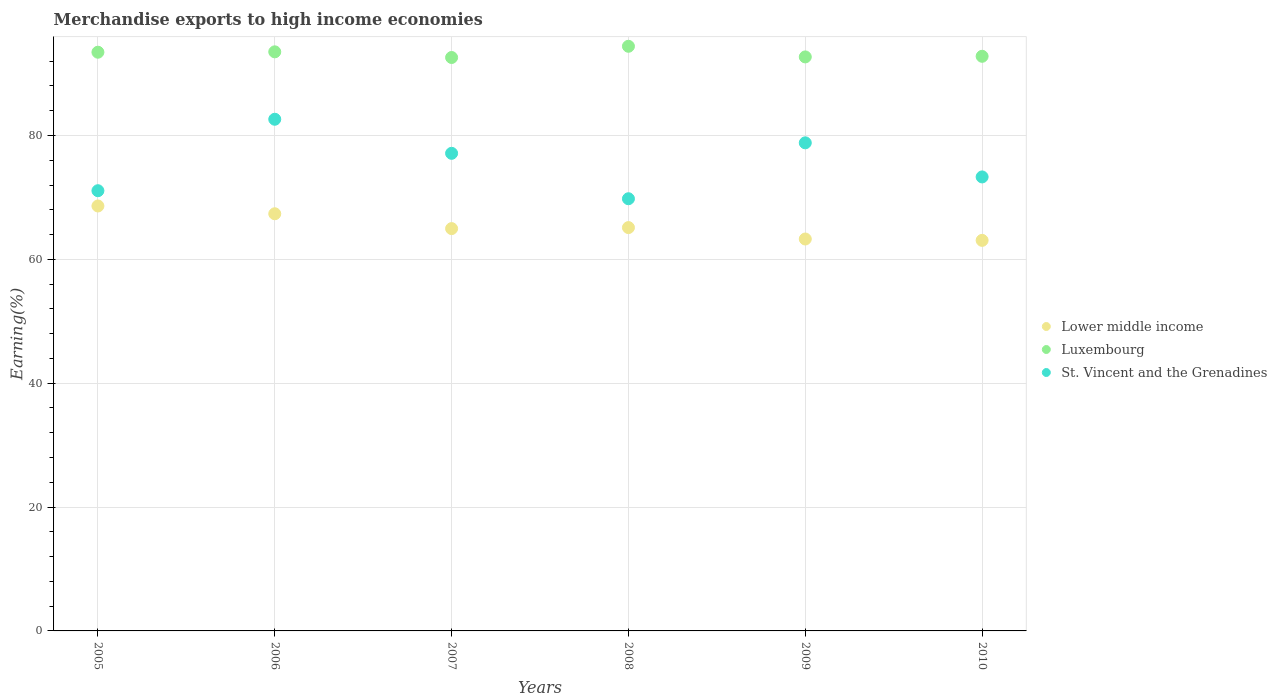How many different coloured dotlines are there?
Keep it short and to the point. 3. Is the number of dotlines equal to the number of legend labels?
Provide a short and direct response. Yes. What is the percentage of amount earned from merchandise exports in St. Vincent and the Grenadines in 2008?
Provide a succinct answer. 69.79. Across all years, what is the maximum percentage of amount earned from merchandise exports in Lower middle income?
Your response must be concise. 68.62. Across all years, what is the minimum percentage of amount earned from merchandise exports in Luxembourg?
Offer a very short reply. 92.6. What is the total percentage of amount earned from merchandise exports in Lower middle income in the graph?
Ensure brevity in your answer.  392.45. What is the difference between the percentage of amount earned from merchandise exports in St. Vincent and the Grenadines in 2005 and that in 2010?
Give a very brief answer. -2.23. What is the difference between the percentage of amount earned from merchandise exports in Luxembourg in 2010 and the percentage of amount earned from merchandise exports in St. Vincent and the Grenadines in 2009?
Make the answer very short. 13.98. What is the average percentage of amount earned from merchandise exports in Lower middle income per year?
Your answer should be compact. 65.41. In the year 2009, what is the difference between the percentage of amount earned from merchandise exports in St. Vincent and the Grenadines and percentage of amount earned from merchandise exports in Lower middle income?
Provide a succinct answer. 15.53. What is the ratio of the percentage of amount earned from merchandise exports in Lower middle income in 2005 to that in 2006?
Make the answer very short. 1.02. Is the difference between the percentage of amount earned from merchandise exports in St. Vincent and the Grenadines in 2006 and 2010 greater than the difference between the percentage of amount earned from merchandise exports in Lower middle income in 2006 and 2010?
Offer a terse response. Yes. What is the difference between the highest and the second highest percentage of amount earned from merchandise exports in St. Vincent and the Grenadines?
Your answer should be very brief. 3.81. What is the difference between the highest and the lowest percentage of amount earned from merchandise exports in Lower middle income?
Your answer should be compact. 5.55. In how many years, is the percentage of amount earned from merchandise exports in Luxembourg greater than the average percentage of amount earned from merchandise exports in Luxembourg taken over all years?
Offer a terse response. 3. Is it the case that in every year, the sum of the percentage of amount earned from merchandise exports in Lower middle income and percentage of amount earned from merchandise exports in Luxembourg  is greater than the percentage of amount earned from merchandise exports in St. Vincent and the Grenadines?
Offer a very short reply. Yes. Does the percentage of amount earned from merchandise exports in Lower middle income monotonically increase over the years?
Provide a succinct answer. No. Is the percentage of amount earned from merchandise exports in Lower middle income strictly greater than the percentage of amount earned from merchandise exports in St. Vincent and the Grenadines over the years?
Provide a succinct answer. No. How many dotlines are there?
Offer a terse response. 3. Does the graph contain grids?
Ensure brevity in your answer.  Yes. Where does the legend appear in the graph?
Your response must be concise. Center right. How are the legend labels stacked?
Provide a short and direct response. Vertical. What is the title of the graph?
Ensure brevity in your answer.  Merchandise exports to high income economies. What is the label or title of the X-axis?
Your answer should be very brief. Years. What is the label or title of the Y-axis?
Offer a very short reply. Earning(%). What is the Earning(%) in Lower middle income in 2005?
Keep it short and to the point. 68.62. What is the Earning(%) in Luxembourg in 2005?
Your answer should be very brief. 93.45. What is the Earning(%) of St. Vincent and the Grenadines in 2005?
Give a very brief answer. 71.09. What is the Earning(%) in Lower middle income in 2006?
Provide a short and direct response. 67.37. What is the Earning(%) in Luxembourg in 2006?
Your answer should be compact. 93.52. What is the Earning(%) in St. Vincent and the Grenadines in 2006?
Offer a terse response. 82.63. What is the Earning(%) of Lower middle income in 2007?
Your response must be concise. 64.97. What is the Earning(%) in Luxembourg in 2007?
Give a very brief answer. 92.6. What is the Earning(%) of St. Vincent and the Grenadines in 2007?
Provide a succinct answer. 77.13. What is the Earning(%) of Lower middle income in 2008?
Keep it short and to the point. 65.13. What is the Earning(%) in Luxembourg in 2008?
Your answer should be very brief. 94.41. What is the Earning(%) of St. Vincent and the Grenadines in 2008?
Keep it short and to the point. 69.79. What is the Earning(%) of Lower middle income in 2009?
Ensure brevity in your answer.  63.29. What is the Earning(%) of Luxembourg in 2009?
Make the answer very short. 92.69. What is the Earning(%) of St. Vincent and the Grenadines in 2009?
Make the answer very short. 78.82. What is the Earning(%) in Lower middle income in 2010?
Your answer should be very brief. 63.07. What is the Earning(%) of Luxembourg in 2010?
Your answer should be very brief. 92.79. What is the Earning(%) in St. Vincent and the Grenadines in 2010?
Make the answer very short. 73.31. Across all years, what is the maximum Earning(%) of Lower middle income?
Your answer should be very brief. 68.62. Across all years, what is the maximum Earning(%) in Luxembourg?
Your answer should be compact. 94.41. Across all years, what is the maximum Earning(%) in St. Vincent and the Grenadines?
Your response must be concise. 82.63. Across all years, what is the minimum Earning(%) in Lower middle income?
Give a very brief answer. 63.07. Across all years, what is the minimum Earning(%) of Luxembourg?
Make the answer very short. 92.6. Across all years, what is the minimum Earning(%) in St. Vincent and the Grenadines?
Offer a very short reply. 69.79. What is the total Earning(%) of Lower middle income in the graph?
Offer a terse response. 392.45. What is the total Earning(%) in Luxembourg in the graph?
Offer a very short reply. 559.47. What is the total Earning(%) in St. Vincent and the Grenadines in the graph?
Offer a terse response. 452.76. What is the difference between the Earning(%) of Lower middle income in 2005 and that in 2006?
Provide a short and direct response. 1.26. What is the difference between the Earning(%) of Luxembourg in 2005 and that in 2006?
Your answer should be compact. -0.06. What is the difference between the Earning(%) in St. Vincent and the Grenadines in 2005 and that in 2006?
Provide a short and direct response. -11.54. What is the difference between the Earning(%) in Lower middle income in 2005 and that in 2007?
Provide a succinct answer. 3.65. What is the difference between the Earning(%) of Luxembourg in 2005 and that in 2007?
Give a very brief answer. 0.85. What is the difference between the Earning(%) in St. Vincent and the Grenadines in 2005 and that in 2007?
Your answer should be compact. -6.04. What is the difference between the Earning(%) of Lower middle income in 2005 and that in 2008?
Offer a very short reply. 3.49. What is the difference between the Earning(%) of Luxembourg in 2005 and that in 2008?
Make the answer very short. -0.96. What is the difference between the Earning(%) of St. Vincent and the Grenadines in 2005 and that in 2008?
Your response must be concise. 1.3. What is the difference between the Earning(%) in Lower middle income in 2005 and that in 2009?
Provide a succinct answer. 5.33. What is the difference between the Earning(%) of Luxembourg in 2005 and that in 2009?
Provide a short and direct response. 0.76. What is the difference between the Earning(%) in St. Vincent and the Grenadines in 2005 and that in 2009?
Your answer should be compact. -7.73. What is the difference between the Earning(%) in Lower middle income in 2005 and that in 2010?
Your answer should be compact. 5.55. What is the difference between the Earning(%) in Luxembourg in 2005 and that in 2010?
Provide a short and direct response. 0.66. What is the difference between the Earning(%) in St. Vincent and the Grenadines in 2005 and that in 2010?
Make the answer very short. -2.23. What is the difference between the Earning(%) of Lower middle income in 2006 and that in 2007?
Your answer should be very brief. 2.4. What is the difference between the Earning(%) in Luxembourg in 2006 and that in 2007?
Keep it short and to the point. 0.91. What is the difference between the Earning(%) in St. Vincent and the Grenadines in 2006 and that in 2007?
Ensure brevity in your answer.  5.5. What is the difference between the Earning(%) of Lower middle income in 2006 and that in 2008?
Your answer should be compact. 2.23. What is the difference between the Earning(%) in Luxembourg in 2006 and that in 2008?
Ensure brevity in your answer.  -0.9. What is the difference between the Earning(%) of St. Vincent and the Grenadines in 2006 and that in 2008?
Offer a terse response. 12.84. What is the difference between the Earning(%) of Lower middle income in 2006 and that in 2009?
Keep it short and to the point. 4.08. What is the difference between the Earning(%) of Luxembourg in 2006 and that in 2009?
Your answer should be very brief. 0.82. What is the difference between the Earning(%) in St. Vincent and the Grenadines in 2006 and that in 2009?
Your answer should be very brief. 3.81. What is the difference between the Earning(%) in Lower middle income in 2006 and that in 2010?
Make the answer very short. 4.3. What is the difference between the Earning(%) in Luxembourg in 2006 and that in 2010?
Offer a terse response. 0.72. What is the difference between the Earning(%) in St. Vincent and the Grenadines in 2006 and that in 2010?
Provide a succinct answer. 9.31. What is the difference between the Earning(%) of Lower middle income in 2007 and that in 2008?
Ensure brevity in your answer.  -0.16. What is the difference between the Earning(%) of Luxembourg in 2007 and that in 2008?
Ensure brevity in your answer.  -1.81. What is the difference between the Earning(%) in St. Vincent and the Grenadines in 2007 and that in 2008?
Your response must be concise. 7.34. What is the difference between the Earning(%) in Lower middle income in 2007 and that in 2009?
Provide a short and direct response. 1.68. What is the difference between the Earning(%) of Luxembourg in 2007 and that in 2009?
Offer a terse response. -0.09. What is the difference between the Earning(%) of St. Vincent and the Grenadines in 2007 and that in 2009?
Offer a very short reply. -1.69. What is the difference between the Earning(%) in Lower middle income in 2007 and that in 2010?
Provide a succinct answer. 1.9. What is the difference between the Earning(%) of Luxembourg in 2007 and that in 2010?
Ensure brevity in your answer.  -0.19. What is the difference between the Earning(%) in St. Vincent and the Grenadines in 2007 and that in 2010?
Ensure brevity in your answer.  3.81. What is the difference between the Earning(%) in Lower middle income in 2008 and that in 2009?
Your answer should be very brief. 1.84. What is the difference between the Earning(%) of Luxembourg in 2008 and that in 2009?
Make the answer very short. 1.72. What is the difference between the Earning(%) in St. Vincent and the Grenadines in 2008 and that in 2009?
Provide a short and direct response. -9.03. What is the difference between the Earning(%) in Lower middle income in 2008 and that in 2010?
Your response must be concise. 2.06. What is the difference between the Earning(%) of Luxembourg in 2008 and that in 2010?
Ensure brevity in your answer.  1.62. What is the difference between the Earning(%) of St. Vincent and the Grenadines in 2008 and that in 2010?
Give a very brief answer. -3.52. What is the difference between the Earning(%) in Lower middle income in 2009 and that in 2010?
Provide a short and direct response. 0.22. What is the difference between the Earning(%) of Luxembourg in 2009 and that in 2010?
Make the answer very short. -0.1. What is the difference between the Earning(%) in St. Vincent and the Grenadines in 2009 and that in 2010?
Make the answer very short. 5.51. What is the difference between the Earning(%) of Lower middle income in 2005 and the Earning(%) of Luxembourg in 2006?
Offer a very short reply. -24.89. What is the difference between the Earning(%) of Lower middle income in 2005 and the Earning(%) of St. Vincent and the Grenadines in 2006?
Offer a terse response. -14. What is the difference between the Earning(%) in Luxembourg in 2005 and the Earning(%) in St. Vincent and the Grenadines in 2006?
Provide a succinct answer. 10.83. What is the difference between the Earning(%) of Lower middle income in 2005 and the Earning(%) of Luxembourg in 2007?
Make the answer very short. -23.98. What is the difference between the Earning(%) of Lower middle income in 2005 and the Earning(%) of St. Vincent and the Grenadines in 2007?
Keep it short and to the point. -8.5. What is the difference between the Earning(%) of Luxembourg in 2005 and the Earning(%) of St. Vincent and the Grenadines in 2007?
Give a very brief answer. 16.33. What is the difference between the Earning(%) in Lower middle income in 2005 and the Earning(%) in Luxembourg in 2008?
Provide a succinct answer. -25.79. What is the difference between the Earning(%) of Lower middle income in 2005 and the Earning(%) of St. Vincent and the Grenadines in 2008?
Give a very brief answer. -1.17. What is the difference between the Earning(%) in Luxembourg in 2005 and the Earning(%) in St. Vincent and the Grenadines in 2008?
Make the answer very short. 23.66. What is the difference between the Earning(%) in Lower middle income in 2005 and the Earning(%) in Luxembourg in 2009?
Offer a very short reply. -24.07. What is the difference between the Earning(%) of Lower middle income in 2005 and the Earning(%) of St. Vincent and the Grenadines in 2009?
Provide a short and direct response. -10.2. What is the difference between the Earning(%) of Luxembourg in 2005 and the Earning(%) of St. Vincent and the Grenadines in 2009?
Your answer should be compact. 14.63. What is the difference between the Earning(%) of Lower middle income in 2005 and the Earning(%) of Luxembourg in 2010?
Your answer should be very brief. -24.17. What is the difference between the Earning(%) of Lower middle income in 2005 and the Earning(%) of St. Vincent and the Grenadines in 2010?
Keep it short and to the point. -4.69. What is the difference between the Earning(%) of Luxembourg in 2005 and the Earning(%) of St. Vincent and the Grenadines in 2010?
Offer a very short reply. 20.14. What is the difference between the Earning(%) in Lower middle income in 2006 and the Earning(%) in Luxembourg in 2007?
Ensure brevity in your answer.  -25.23. What is the difference between the Earning(%) of Lower middle income in 2006 and the Earning(%) of St. Vincent and the Grenadines in 2007?
Ensure brevity in your answer.  -9.76. What is the difference between the Earning(%) in Luxembourg in 2006 and the Earning(%) in St. Vincent and the Grenadines in 2007?
Keep it short and to the point. 16.39. What is the difference between the Earning(%) in Lower middle income in 2006 and the Earning(%) in Luxembourg in 2008?
Your answer should be very brief. -27.05. What is the difference between the Earning(%) of Lower middle income in 2006 and the Earning(%) of St. Vincent and the Grenadines in 2008?
Your response must be concise. -2.42. What is the difference between the Earning(%) of Luxembourg in 2006 and the Earning(%) of St. Vincent and the Grenadines in 2008?
Your response must be concise. 23.72. What is the difference between the Earning(%) in Lower middle income in 2006 and the Earning(%) in Luxembourg in 2009?
Give a very brief answer. -25.33. What is the difference between the Earning(%) of Lower middle income in 2006 and the Earning(%) of St. Vincent and the Grenadines in 2009?
Your response must be concise. -11.45. What is the difference between the Earning(%) in Luxembourg in 2006 and the Earning(%) in St. Vincent and the Grenadines in 2009?
Ensure brevity in your answer.  14.7. What is the difference between the Earning(%) of Lower middle income in 2006 and the Earning(%) of Luxembourg in 2010?
Offer a very short reply. -25.43. What is the difference between the Earning(%) of Lower middle income in 2006 and the Earning(%) of St. Vincent and the Grenadines in 2010?
Provide a short and direct response. -5.95. What is the difference between the Earning(%) in Luxembourg in 2006 and the Earning(%) in St. Vincent and the Grenadines in 2010?
Provide a succinct answer. 20.2. What is the difference between the Earning(%) in Lower middle income in 2007 and the Earning(%) in Luxembourg in 2008?
Provide a short and direct response. -29.44. What is the difference between the Earning(%) in Lower middle income in 2007 and the Earning(%) in St. Vincent and the Grenadines in 2008?
Make the answer very short. -4.82. What is the difference between the Earning(%) in Luxembourg in 2007 and the Earning(%) in St. Vincent and the Grenadines in 2008?
Provide a short and direct response. 22.81. What is the difference between the Earning(%) of Lower middle income in 2007 and the Earning(%) of Luxembourg in 2009?
Offer a terse response. -27.72. What is the difference between the Earning(%) in Lower middle income in 2007 and the Earning(%) in St. Vincent and the Grenadines in 2009?
Give a very brief answer. -13.85. What is the difference between the Earning(%) in Luxembourg in 2007 and the Earning(%) in St. Vincent and the Grenadines in 2009?
Provide a succinct answer. 13.78. What is the difference between the Earning(%) in Lower middle income in 2007 and the Earning(%) in Luxembourg in 2010?
Your answer should be very brief. -27.83. What is the difference between the Earning(%) of Lower middle income in 2007 and the Earning(%) of St. Vincent and the Grenadines in 2010?
Keep it short and to the point. -8.34. What is the difference between the Earning(%) of Luxembourg in 2007 and the Earning(%) of St. Vincent and the Grenadines in 2010?
Your answer should be very brief. 19.29. What is the difference between the Earning(%) of Lower middle income in 2008 and the Earning(%) of Luxembourg in 2009?
Your answer should be very brief. -27.56. What is the difference between the Earning(%) in Lower middle income in 2008 and the Earning(%) in St. Vincent and the Grenadines in 2009?
Offer a very short reply. -13.69. What is the difference between the Earning(%) of Luxembourg in 2008 and the Earning(%) of St. Vincent and the Grenadines in 2009?
Make the answer very short. 15.59. What is the difference between the Earning(%) of Lower middle income in 2008 and the Earning(%) of Luxembourg in 2010?
Make the answer very short. -27.66. What is the difference between the Earning(%) of Lower middle income in 2008 and the Earning(%) of St. Vincent and the Grenadines in 2010?
Ensure brevity in your answer.  -8.18. What is the difference between the Earning(%) of Luxembourg in 2008 and the Earning(%) of St. Vincent and the Grenadines in 2010?
Offer a very short reply. 21.1. What is the difference between the Earning(%) in Lower middle income in 2009 and the Earning(%) in Luxembourg in 2010?
Make the answer very short. -29.51. What is the difference between the Earning(%) in Lower middle income in 2009 and the Earning(%) in St. Vincent and the Grenadines in 2010?
Give a very brief answer. -10.02. What is the difference between the Earning(%) in Luxembourg in 2009 and the Earning(%) in St. Vincent and the Grenadines in 2010?
Give a very brief answer. 19.38. What is the average Earning(%) in Lower middle income per year?
Offer a terse response. 65.41. What is the average Earning(%) in Luxembourg per year?
Offer a terse response. 93.25. What is the average Earning(%) in St. Vincent and the Grenadines per year?
Your response must be concise. 75.46. In the year 2005, what is the difference between the Earning(%) of Lower middle income and Earning(%) of Luxembourg?
Offer a terse response. -24.83. In the year 2005, what is the difference between the Earning(%) of Lower middle income and Earning(%) of St. Vincent and the Grenadines?
Keep it short and to the point. -2.46. In the year 2005, what is the difference between the Earning(%) in Luxembourg and Earning(%) in St. Vincent and the Grenadines?
Make the answer very short. 22.37. In the year 2006, what is the difference between the Earning(%) of Lower middle income and Earning(%) of Luxembourg?
Your answer should be very brief. -26.15. In the year 2006, what is the difference between the Earning(%) in Lower middle income and Earning(%) in St. Vincent and the Grenadines?
Your answer should be compact. -15.26. In the year 2006, what is the difference between the Earning(%) in Luxembourg and Earning(%) in St. Vincent and the Grenadines?
Provide a succinct answer. 10.89. In the year 2007, what is the difference between the Earning(%) in Lower middle income and Earning(%) in Luxembourg?
Keep it short and to the point. -27.63. In the year 2007, what is the difference between the Earning(%) in Lower middle income and Earning(%) in St. Vincent and the Grenadines?
Provide a succinct answer. -12.16. In the year 2007, what is the difference between the Earning(%) in Luxembourg and Earning(%) in St. Vincent and the Grenadines?
Keep it short and to the point. 15.47. In the year 2008, what is the difference between the Earning(%) of Lower middle income and Earning(%) of Luxembourg?
Give a very brief answer. -29.28. In the year 2008, what is the difference between the Earning(%) of Lower middle income and Earning(%) of St. Vincent and the Grenadines?
Your answer should be compact. -4.66. In the year 2008, what is the difference between the Earning(%) of Luxembourg and Earning(%) of St. Vincent and the Grenadines?
Ensure brevity in your answer.  24.62. In the year 2009, what is the difference between the Earning(%) in Lower middle income and Earning(%) in Luxembourg?
Make the answer very short. -29.41. In the year 2009, what is the difference between the Earning(%) of Lower middle income and Earning(%) of St. Vincent and the Grenadines?
Your response must be concise. -15.53. In the year 2009, what is the difference between the Earning(%) of Luxembourg and Earning(%) of St. Vincent and the Grenadines?
Provide a short and direct response. 13.87. In the year 2010, what is the difference between the Earning(%) of Lower middle income and Earning(%) of Luxembourg?
Your answer should be compact. -29.73. In the year 2010, what is the difference between the Earning(%) of Lower middle income and Earning(%) of St. Vincent and the Grenadines?
Your answer should be very brief. -10.24. In the year 2010, what is the difference between the Earning(%) of Luxembourg and Earning(%) of St. Vincent and the Grenadines?
Provide a short and direct response. 19.48. What is the ratio of the Earning(%) in Lower middle income in 2005 to that in 2006?
Offer a terse response. 1.02. What is the ratio of the Earning(%) in Luxembourg in 2005 to that in 2006?
Offer a terse response. 1. What is the ratio of the Earning(%) in St. Vincent and the Grenadines in 2005 to that in 2006?
Provide a short and direct response. 0.86. What is the ratio of the Earning(%) of Lower middle income in 2005 to that in 2007?
Your answer should be compact. 1.06. What is the ratio of the Earning(%) in Luxembourg in 2005 to that in 2007?
Offer a very short reply. 1.01. What is the ratio of the Earning(%) in St. Vincent and the Grenadines in 2005 to that in 2007?
Offer a terse response. 0.92. What is the ratio of the Earning(%) of Lower middle income in 2005 to that in 2008?
Offer a terse response. 1.05. What is the ratio of the Earning(%) of St. Vincent and the Grenadines in 2005 to that in 2008?
Ensure brevity in your answer.  1.02. What is the ratio of the Earning(%) of Lower middle income in 2005 to that in 2009?
Make the answer very short. 1.08. What is the ratio of the Earning(%) in Luxembourg in 2005 to that in 2009?
Your response must be concise. 1.01. What is the ratio of the Earning(%) of St. Vincent and the Grenadines in 2005 to that in 2009?
Give a very brief answer. 0.9. What is the ratio of the Earning(%) of Lower middle income in 2005 to that in 2010?
Your answer should be very brief. 1.09. What is the ratio of the Earning(%) in Luxembourg in 2005 to that in 2010?
Your response must be concise. 1.01. What is the ratio of the Earning(%) in St. Vincent and the Grenadines in 2005 to that in 2010?
Ensure brevity in your answer.  0.97. What is the ratio of the Earning(%) of Lower middle income in 2006 to that in 2007?
Offer a very short reply. 1.04. What is the ratio of the Earning(%) of Luxembourg in 2006 to that in 2007?
Keep it short and to the point. 1.01. What is the ratio of the Earning(%) of St. Vincent and the Grenadines in 2006 to that in 2007?
Provide a short and direct response. 1.07. What is the ratio of the Earning(%) in Lower middle income in 2006 to that in 2008?
Your answer should be very brief. 1.03. What is the ratio of the Earning(%) of Luxembourg in 2006 to that in 2008?
Ensure brevity in your answer.  0.99. What is the ratio of the Earning(%) in St. Vincent and the Grenadines in 2006 to that in 2008?
Make the answer very short. 1.18. What is the ratio of the Earning(%) of Lower middle income in 2006 to that in 2009?
Ensure brevity in your answer.  1.06. What is the ratio of the Earning(%) in Luxembourg in 2006 to that in 2009?
Offer a terse response. 1.01. What is the ratio of the Earning(%) in St. Vincent and the Grenadines in 2006 to that in 2009?
Make the answer very short. 1.05. What is the ratio of the Earning(%) of Lower middle income in 2006 to that in 2010?
Offer a very short reply. 1.07. What is the ratio of the Earning(%) of Luxembourg in 2006 to that in 2010?
Your answer should be compact. 1.01. What is the ratio of the Earning(%) in St. Vincent and the Grenadines in 2006 to that in 2010?
Keep it short and to the point. 1.13. What is the ratio of the Earning(%) in Luxembourg in 2007 to that in 2008?
Your answer should be compact. 0.98. What is the ratio of the Earning(%) of St. Vincent and the Grenadines in 2007 to that in 2008?
Your answer should be compact. 1.11. What is the ratio of the Earning(%) of Lower middle income in 2007 to that in 2009?
Give a very brief answer. 1.03. What is the ratio of the Earning(%) of St. Vincent and the Grenadines in 2007 to that in 2009?
Make the answer very short. 0.98. What is the ratio of the Earning(%) in Lower middle income in 2007 to that in 2010?
Your response must be concise. 1.03. What is the ratio of the Earning(%) in Luxembourg in 2007 to that in 2010?
Your answer should be very brief. 1. What is the ratio of the Earning(%) of St. Vincent and the Grenadines in 2007 to that in 2010?
Offer a terse response. 1.05. What is the ratio of the Earning(%) in Lower middle income in 2008 to that in 2009?
Provide a short and direct response. 1.03. What is the ratio of the Earning(%) in Luxembourg in 2008 to that in 2009?
Ensure brevity in your answer.  1.02. What is the ratio of the Earning(%) of St. Vincent and the Grenadines in 2008 to that in 2009?
Your answer should be very brief. 0.89. What is the ratio of the Earning(%) in Lower middle income in 2008 to that in 2010?
Provide a short and direct response. 1.03. What is the ratio of the Earning(%) in Luxembourg in 2008 to that in 2010?
Provide a short and direct response. 1.02. What is the ratio of the Earning(%) in St. Vincent and the Grenadines in 2008 to that in 2010?
Keep it short and to the point. 0.95. What is the ratio of the Earning(%) in Lower middle income in 2009 to that in 2010?
Offer a very short reply. 1. What is the ratio of the Earning(%) of St. Vincent and the Grenadines in 2009 to that in 2010?
Provide a succinct answer. 1.08. What is the difference between the highest and the second highest Earning(%) of Lower middle income?
Provide a short and direct response. 1.26. What is the difference between the highest and the second highest Earning(%) in Luxembourg?
Keep it short and to the point. 0.9. What is the difference between the highest and the second highest Earning(%) in St. Vincent and the Grenadines?
Your response must be concise. 3.81. What is the difference between the highest and the lowest Earning(%) of Lower middle income?
Ensure brevity in your answer.  5.55. What is the difference between the highest and the lowest Earning(%) in Luxembourg?
Provide a short and direct response. 1.81. What is the difference between the highest and the lowest Earning(%) of St. Vincent and the Grenadines?
Give a very brief answer. 12.84. 